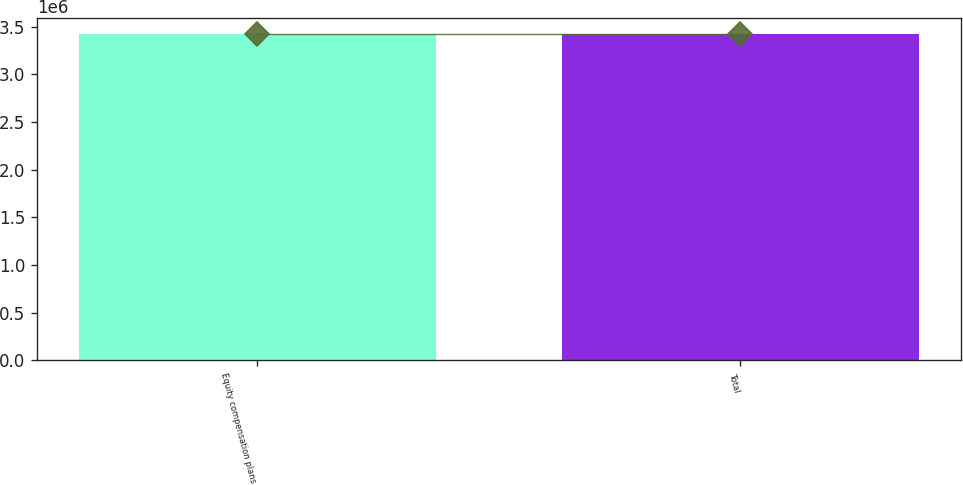Convert chart. <chart><loc_0><loc_0><loc_500><loc_500><bar_chart><fcel>Equity compensation plans<fcel>Total<nl><fcel>3.4196e+06<fcel>3.4196e+06<nl></chart> 